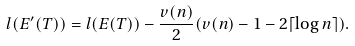Convert formula to latex. <formula><loc_0><loc_0><loc_500><loc_500>l ( E ^ { \prime } ( T ) ) = l ( E ( T ) ) - \frac { v ( n ) } { 2 } ( v ( n ) - 1 - 2 \lceil \log n \rceil ) .</formula> 